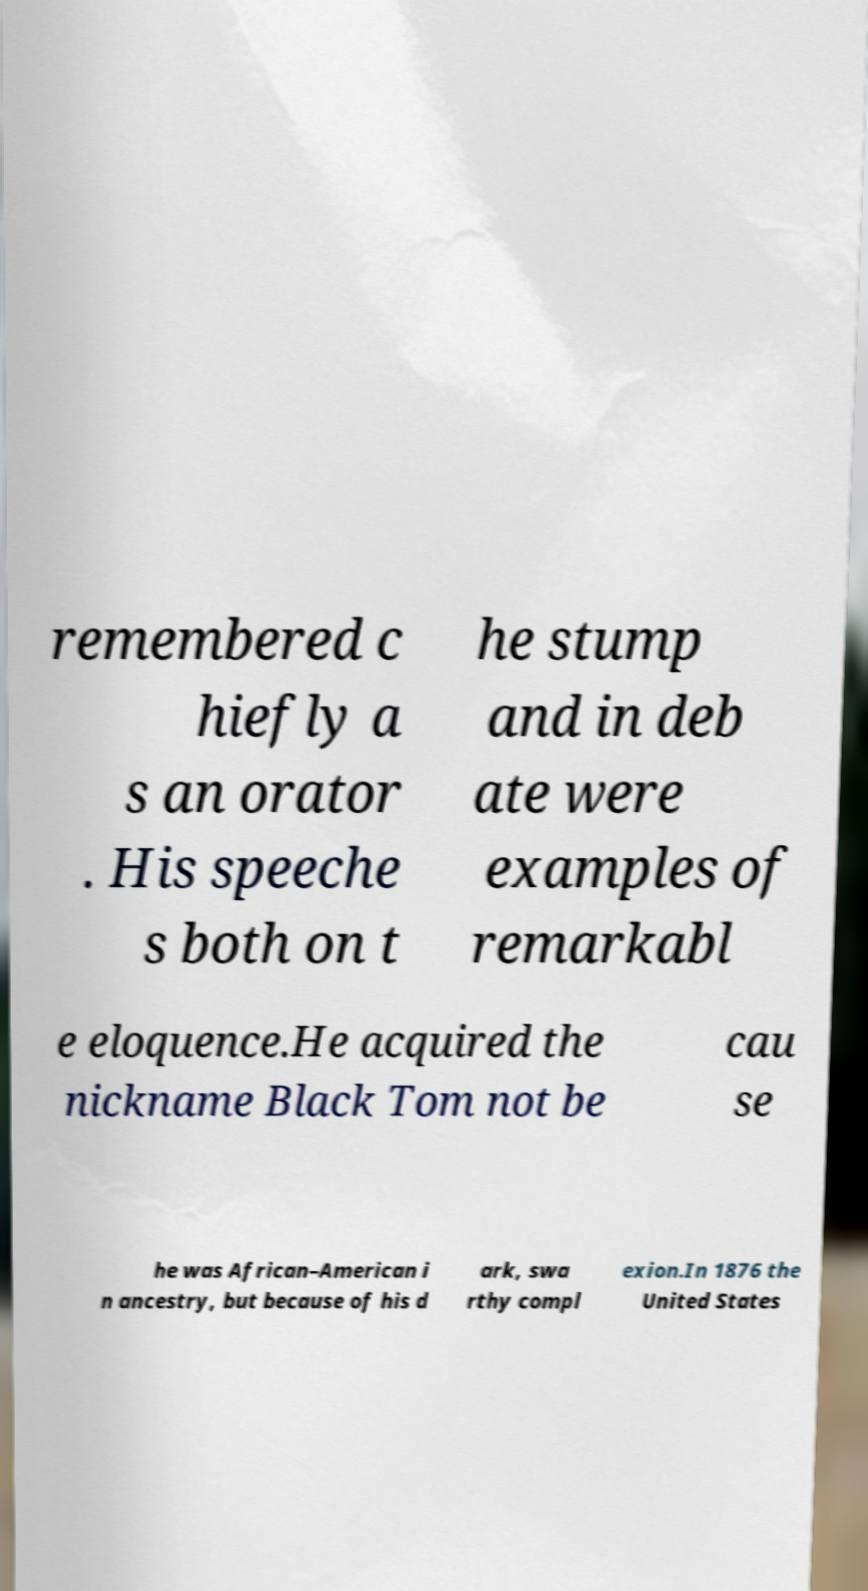Can you read and provide the text displayed in the image?This photo seems to have some interesting text. Can you extract and type it out for me? remembered c hiefly a s an orator . His speeche s both on t he stump and in deb ate were examples of remarkabl e eloquence.He acquired the nickname Black Tom not be cau se he was African–American i n ancestry, but because of his d ark, swa rthy compl exion.In 1876 the United States 